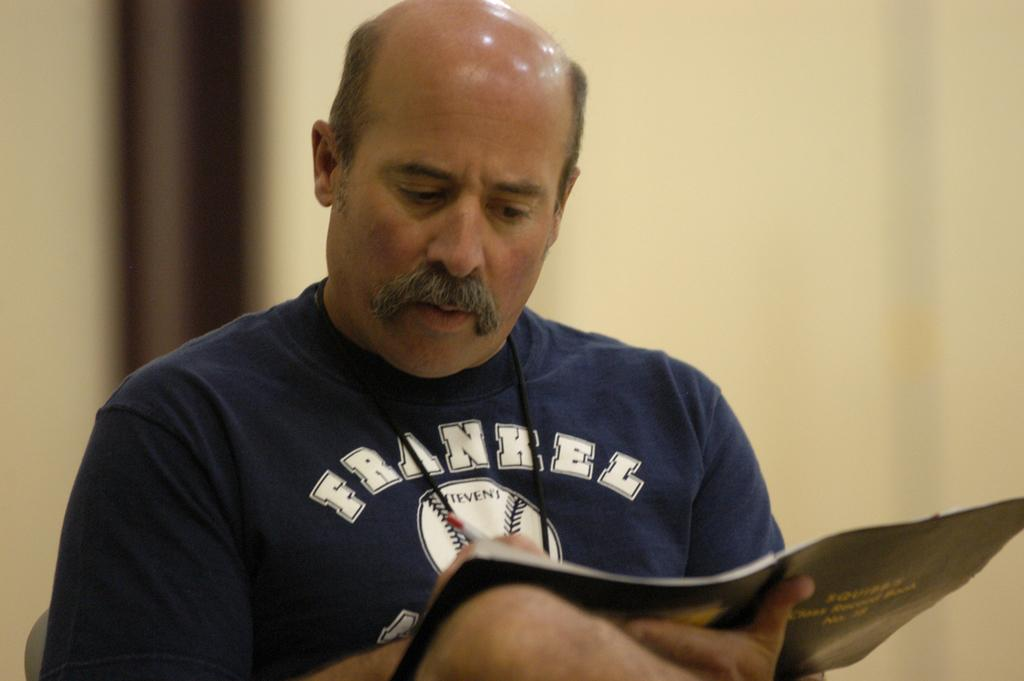Provide a one-sentence caption for the provided image. A man with very little hair, wearing a Frankel shirt, reads a magazine. 